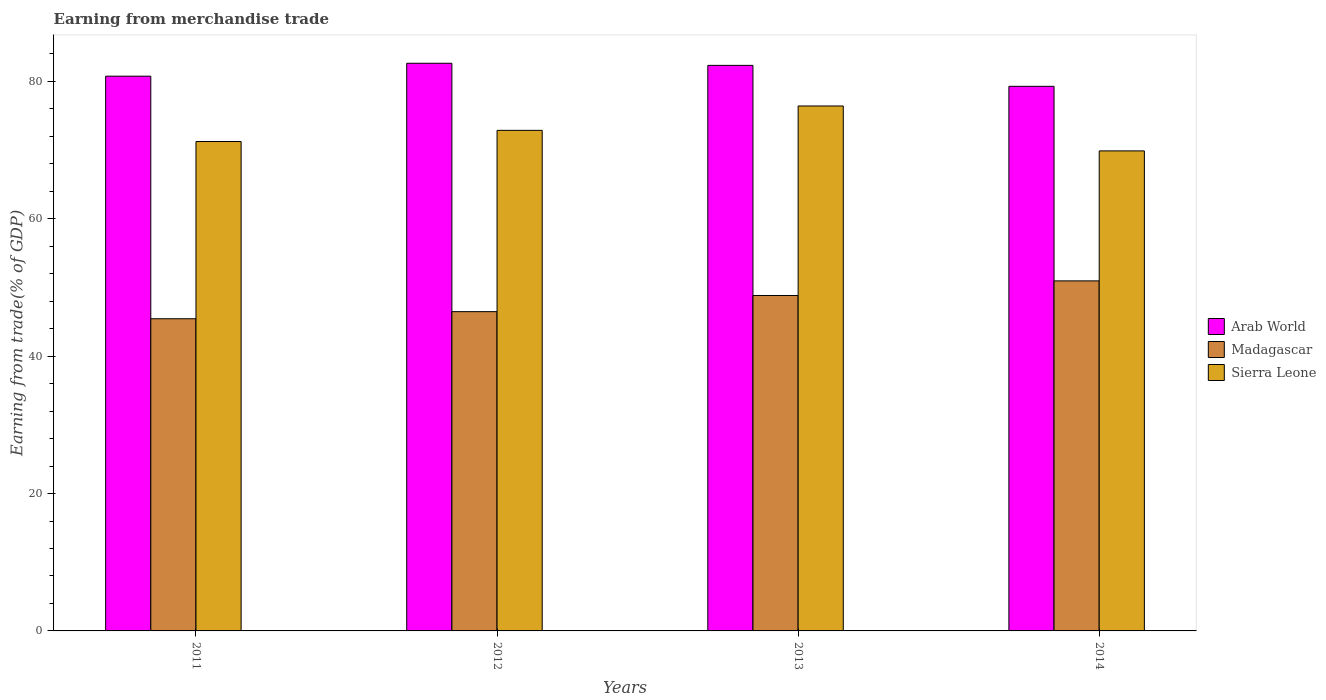How many different coloured bars are there?
Offer a terse response. 3. Are the number of bars on each tick of the X-axis equal?
Your answer should be compact. Yes. How many bars are there on the 4th tick from the left?
Make the answer very short. 3. How many bars are there on the 2nd tick from the right?
Ensure brevity in your answer.  3. What is the earnings from trade in Arab World in 2012?
Keep it short and to the point. 82.63. Across all years, what is the maximum earnings from trade in Madagascar?
Provide a short and direct response. 50.95. Across all years, what is the minimum earnings from trade in Madagascar?
Offer a very short reply. 45.44. What is the total earnings from trade in Madagascar in the graph?
Ensure brevity in your answer.  191.69. What is the difference between the earnings from trade in Madagascar in 2011 and that in 2012?
Keep it short and to the point. -1.03. What is the difference between the earnings from trade in Madagascar in 2014 and the earnings from trade in Arab World in 2012?
Ensure brevity in your answer.  -31.68. What is the average earnings from trade in Madagascar per year?
Offer a terse response. 47.92. In the year 2014, what is the difference between the earnings from trade in Madagascar and earnings from trade in Sierra Leone?
Provide a short and direct response. -18.92. What is the ratio of the earnings from trade in Sierra Leone in 2013 to that in 2014?
Provide a succinct answer. 1.09. Is the earnings from trade in Sierra Leone in 2011 less than that in 2013?
Keep it short and to the point. Yes. What is the difference between the highest and the second highest earnings from trade in Sierra Leone?
Your answer should be very brief. 3.55. What is the difference between the highest and the lowest earnings from trade in Madagascar?
Your response must be concise. 5.51. In how many years, is the earnings from trade in Sierra Leone greater than the average earnings from trade in Sierra Leone taken over all years?
Provide a short and direct response. 2. Is the sum of the earnings from trade in Arab World in 2011 and 2012 greater than the maximum earnings from trade in Sierra Leone across all years?
Give a very brief answer. Yes. What does the 1st bar from the left in 2011 represents?
Give a very brief answer. Arab World. What does the 3rd bar from the right in 2011 represents?
Your answer should be compact. Arab World. How many bars are there?
Your response must be concise. 12. What is the difference between two consecutive major ticks on the Y-axis?
Give a very brief answer. 20. Does the graph contain any zero values?
Keep it short and to the point. No. Does the graph contain grids?
Your answer should be very brief. No. Where does the legend appear in the graph?
Your response must be concise. Center right. How are the legend labels stacked?
Offer a very short reply. Vertical. What is the title of the graph?
Offer a terse response. Earning from merchandise trade. Does "Middle East & North Africa (developing only)" appear as one of the legend labels in the graph?
Provide a short and direct response. No. What is the label or title of the X-axis?
Ensure brevity in your answer.  Years. What is the label or title of the Y-axis?
Keep it short and to the point. Earning from trade(% of GDP). What is the Earning from trade(% of GDP) of Arab World in 2011?
Provide a short and direct response. 80.75. What is the Earning from trade(% of GDP) in Madagascar in 2011?
Ensure brevity in your answer.  45.44. What is the Earning from trade(% of GDP) of Sierra Leone in 2011?
Offer a terse response. 71.24. What is the Earning from trade(% of GDP) of Arab World in 2012?
Give a very brief answer. 82.63. What is the Earning from trade(% of GDP) of Madagascar in 2012?
Provide a short and direct response. 46.47. What is the Earning from trade(% of GDP) in Sierra Leone in 2012?
Your answer should be very brief. 72.86. What is the Earning from trade(% of GDP) in Arab World in 2013?
Make the answer very short. 82.32. What is the Earning from trade(% of GDP) in Madagascar in 2013?
Offer a very short reply. 48.83. What is the Earning from trade(% of GDP) in Sierra Leone in 2013?
Keep it short and to the point. 76.41. What is the Earning from trade(% of GDP) of Arab World in 2014?
Keep it short and to the point. 79.27. What is the Earning from trade(% of GDP) in Madagascar in 2014?
Provide a short and direct response. 50.95. What is the Earning from trade(% of GDP) in Sierra Leone in 2014?
Ensure brevity in your answer.  69.87. Across all years, what is the maximum Earning from trade(% of GDP) of Arab World?
Keep it short and to the point. 82.63. Across all years, what is the maximum Earning from trade(% of GDP) in Madagascar?
Ensure brevity in your answer.  50.95. Across all years, what is the maximum Earning from trade(% of GDP) of Sierra Leone?
Make the answer very short. 76.41. Across all years, what is the minimum Earning from trade(% of GDP) in Arab World?
Offer a terse response. 79.27. Across all years, what is the minimum Earning from trade(% of GDP) in Madagascar?
Your response must be concise. 45.44. Across all years, what is the minimum Earning from trade(% of GDP) of Sierra Leone?
Give a very brief answer. 69.87. What is the total Earning from trade(% of GDP) in Arab World in the graph?
Offer a terse response. 324.98. What is the total Earning from trade(% of GDP) of Madagascar in the graph?
Provide a succinct answer. 191.69. What is the total Earning from trade(% of GDP) in Sierra Leone in the graph?
Your response must be concise. 290.39. What is the difference between the Earning from trade(% of GDP) of Arab World in 2011 and that in 2012?
Provide a short and direct response. -1.88. What is the difference between the Earning from trade(% of GDP) in Madagascar in 2011 and that in 2012?
Your answer should be very brief. -1.03. What is the difference between the Earning from trade(% of GDP) in Sierra Leone in 2011 and that in 2012?
Offer a terse response. -1.63. What is the difference between the Earning from trade(% of GDP) of Arab World in 2011 and that in 2013?
Keep it short and to the point. -1.57. What is the difference between the Earning from trade(% of GDP) of Madagascar in 2011 and that in 2013?
Your response must be concise. -3.38. What is the difference between the Earning from trade(% of GDP) of Sierra Leone in 2011 and that in 2013?
Ensure brevity in your answer.  -5.18. What is the difference between the Earning from trade(% of GDP) of Arab World in 2011 and that in 2014?
Offer a terse response. 1.48. What is the difference between the Earning from trade(% of GDP) in Madagascar in 2011 and that in 2014?
Ensure brevity in your answer.  -5.51. What is the difference between the Earning from trade(% of GDP) of Sierra Leone in 2011 and that in 2014?
Your response must be concise. 1.36. What is the difference between the Earning from trade(% of GDP) in Arab World in 2012 and that in 2013?
Provide a short and direct response. 0.31. What is the difference between the Earning from trade(% of GDP) of Madagascar in 2012 and that in 2013?
Provide a short and direct response. -2.35. What is the difference between the Earning from trade(% of GDP) of Sierra Leone in 2012 and that in 2013?
Your response must be concise. -3.55. What is the difference between the Earning from trade(% of GDP) in Arab World in 2012 and that in 2014?
Ensure brevity in your answer.  3.36. What is the difference between the Earning from trade(% of GDP) in Madagascar in 2012 and that in 2014?
Offer a very short reply. -4.48. What is the difference between the Earning from trade(% of GDP) of Sierra Leone in 2012 and that in 2014?
Your answer should be compact. 2.99. What is the difference between the Earning from trade(% of GDP) in Arab World in 2013 and that in 2014?
Your answer should be very brief. 3.05. What is the difference between the Earning from trade(% of GDP) of Madagascar in 2013 and that in 2014?
Keep it short and to the point. -2.13. What is the difference between the Earning from trade(% of GDP) of Sierra Leone in 2013 and that in 2014?
Make the answer very short. 6.54. What is the difference between the Earning from trade(% of GDP) in Arab World in 2011 and the Earning from trade(% of GDP) in Madagascar in 2012?
Your answer should be very brief. 34.28. What is the difference between the Earning from trade(% of GDP) in Arab World in 2011 and the Earning from trade(% of GDP) in Sierra Leone in 2012?
Make the answer very short. 7.89. What is the difference between the Earning from trade(% of GDP) in Madagascar in 2011 and the Earning from trade(% of GDP) in Sierra Leone in 2012?
Offer a very short reply. -27.42. What is the difference between the Earning from trade(% of GDP) of Arab World in 2011 and the Earning from trade(% of GDP) of Madagascar in 2013?
Offer a terse response. 31.92. What is the difference between the Earning from trade(% of GDP) of Arab World in 2011 and the Earning from trade(% of GDP) of Sierra Leone in 2013?
Make the answer very short. 4.34. What is the difference between the Earning from trade(% of GDP) in Madagascar in 2011 and the Earning from trade(% of GDP) in Sierra Leone in 2013?
Ensure brevity in your answer.  -30.97. What is the difference between the Earning from trade(% of GDP) of Arab World in 2011 and the Earning from trade(% of GDP) of Madagascar in 2014?
Your answer should be very brief. 29.8. What is the difference between the Earning from trade(% of GDP) in Arab World in 2011 and the Earning from trade(% of GDP) in Sierra Leone in 2014?
Your answer should be compact. 10.88. What is the difference between the Earning from trade(% of GDP) of Madagascar in 2011 and the Earning from trade(% of GDP) of Sierra Leone in 2014?
Your answer should be compact. -24.43. What is the difference between the Earning from trade(% of GDP) of Arab World in 2012 and the Earning from trade(% of GDP) of Madagascar in 2013?
Your answer should be very brief. 33.8. What is the difference between the Earning from trade(% of GDP) in Arab World in 2012 and the Earning from trade(% of GDP) in Sierra Leone in 2013?
Your answer should be compact. 6.22. What is the difference between the Earning from trade(% of GDP) in Madagascar in 2012 and the Earning from trade(% of GDP) in Sierra Leone in 2013?
Keep it short and to the point. -29.94. What is the difference between the Earning from trade(% of GDP) in Arab World in 2012 and the Earning from trade(% of GDP) in Madagascar in 2014?
Give a very brief answer. 31.68. What is the difference between the Earning from trade(% of GDP) in Arab World in 2012 and the Earning from trade(% of GDP) in Sierra Leone in 2014?
Give a very brief answer. 12.76. What is the difference between the Earning from trade(% of GDP) in Madagascar in 2012 and the Earning from trade(% of GDP) in Sierra Leone in 2014?
Provide a succinct answer. -23.4. What is the difference between the Earning from trade(% of GDP) of Arab World in 2013 and the Earning from trade(% of GDP) of Madagascar in 2014?
Offer a very short reply. 31.37. What is the difference between the Earning from trade(% of GDP) in Arab World in 2013 and the Earning from trade(% of GDP) in Sierra Leone in 2014?
Ensure brevity in your answer.  12.45. What is the difference between the Earning from trade(% of GDP) in Madagascar in 2013 and the Earning from trade(% of GDP) in Sierra Leone in 2014?
Provide a short and direct response. -21.05. What is the average Earning from trade(% of GDP) in Arab World per year?
Ensure brevity in your answer.  81.24. What is the average Earning from trade(% of GDP) in Madagascar per year?
Ensure brevity in your answer.  47.92. What is the average Earning from trade(% of GDP) in Sierra Leone per year?
Provide a succinct answer. 72.6. In the year 2011, what is the difference between the Earning from trade(% of GDP) of Arab World and Earning from trade(% of GDP) of Madagascar?
Provide a short and direct response. 35.31. In the year 2011, what is the difference between the Earning from trade(% of GDP) of Arab World and Earning from trade(% of GDP) of Sierra Leone?
Provide a short and direct response. 9.51. In the year 2011, what is the difference between the Earning from trade(% of GDP) in Madagascar and Earning from trade(% of GDP) in Sierra Leone?
Your response must be concise. -25.8. In the year 2012, what is the difference between the Earning from trade(% of GDP) of Arab World and Earning from trade(% of GDP) of Madagascar?
Offer a terse response. 36.16. In the year 2012, what is the difference between the Earning from trade(% of GDP) in Arab World and Earning from trade(% of GDP) in Sierra Leone?
Your answer should be very brief. 9.77. In the year 2012, what is the difference between the Earning from trade(% of GDP) in Madagascar and Earning from trade(% of GDP) in Sierra Leone?
Provide a succinct answer. -26.39. In the year 2013, what is the difference between the Earning from trade(% of GDP) of Arab World and Earning from trade(% of GDP) of Madagascar?
Offer a very short reply. 33.5. In the year 2013, what is the difference between the Earning from trade(% of GDP) of Arab World and Earning from trade(% of GDP) of Sierra Leone?
Offer a very short reply. 5.91. In the year 2013, what is the difference between the Earning from trade(% of GDP) in Madagascar and Earning from trade(% of GDP) in Sierra Leone?
Ensure brevity in your answer.  -27.59. In the year 2014, what is the difference between the Earning from trade(% of GDP) in Arab World and Earning from trade(% of GDP) in Madagascar?
Your response must be concise. 28.32. In the year 2014, what is the difference between the Earning from trade(% of GDP) in Arab World and Earning from trade(% of GDP) in Sierra Leone?
Provide a succinct answer. 9.4. In the year 2014, what is the difference between the Earning from trade(% of GDP) in Madagascar and Earning from trade(% of GDP) in Sierra Leone?
Offer a terse response. -18.92. What is the ratio of the Earning from trade(% of GDP) in Arab World in 2011 to that in 2012?
Make the answer very short. 0.98. What is the ratio of the Earning from trade(% of GDP) of Madagascar in 2011 to that in 2012?
Keep it short and to the point. 0.98. What is the ratio of the Earning from trade(% of GDP) in Sierra Leone in 2011 to that in 2012?
Give a very brief answer. 0.98. What is the ratio of the Earning from trade(% of GDP) of Arab World in 2011 to that in 2013?
Your answer should be very brief. 0.98. What is the ratio of the Earning from trade(% of GDP) in Madagascar in 2011 to that in 2013?
Offer a very short reply. 0.93. What is the ratio of the Earning from trade(% of GDP) in Sierra Leone in 2011 to that in 2013?
Your answer should be very brief. 0.93. What is the ratio of the Earning from trade(% of GDP) in Arab World in 2011 to that in 2014?
Make the answer very short. 1.02. What is the ratio of the Earning from trade(% of GDP) of Madagascar in 2011 to that in 2014?
Your answer should be compact. 0.89. What is the ratio of the Earning from trade(% of GDP) of Sierra Leone in 2011 to that in 2014?
Your answer should be very brief. 1.02. What is the ratio of the Earning from trade(% of GDP) of Madagascar in 2012 to that in 2013?
Ensure brevity in your answer.  0.95. What is the ratio of the Earning from trade(% of GDP) of Sierra Leone in 2012 to that in 2013?
Give a very brief answer. 0.95. What is the ratio of the Earning from trade(% of GDP) in Arab World in 2012 to that in 2014?
Provide a succinct answer. 1.04. What is the ratio of the Earning from trade(% of GDP) in Madagascar in 2012 to that in 2014?
Offer a terse response. 0.91. What is the ratio of the Earning from trade(% of GDP) of Sierra Leone in 2012 to that in 2014?
Provide a succinct answer. 1.04. What is the ratio of the Earning from trade(% of GDP) in Arab World in 2013 to that in 2014?
Your answer should be compact. 1.04. What is the ratio of the Earning from trade(% of GDP) in Madagascar in 2013 to that in 2014?
Ensure brevity in your answer.  0.96. What is the ratio of the Earning from trade(% of GDP) of Sierra Leone in 2013 to that in 2014?
Give a very brief answer. 1.09. What is the difference between the highest and the second highest Earning from trade(% of GDP) in Arab World?
Your answer should be very brief. 0.31. What is the difference between the highest and the second highest Earning from trade(% of GDP) of Madagascar?
Give a very brief answer. 2.13. What is the difference between the highest and the second highest Earning from trade(% of GDP) of Sierra Leone?
Offer a very short reply. 3.55. What is the difference between the highest and the lowest Earning from trade(% of GDP) in Arab World?
Make the answer very short. 3.36. What is the difference between the highest and the lowest Earning from trade(% of GDP) of Madagascar?
Your answer should be very brief. 5.51. What is the difference between the highest and the lowest Earning from trade(% of GDP) of Sierra Leone?
Your answer should be compact. 6.54. 